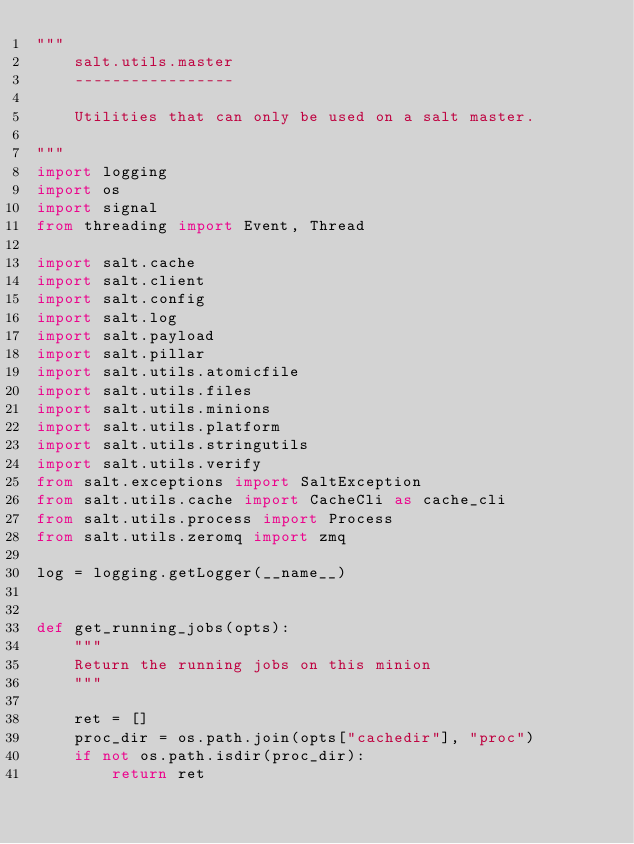Convert code to text. <code><loc_0><loc_0><loc_500><loc_500><_Python_>"""
    salt.utils.master
    -----------------

    Utilities that can only be used on a salt master.

"""
import logging
import os
import signal
from threading import Event, Thread

import salt.cache
import salt.client
import salt.config
import salt.log
import salt.payload
import salt.pillar
import salt.utils.atomicfile
import salt.utils.files
import salt.utils.minions
import salt.utils.platform
import salt.utils.stringutils
import salt.utils.verify
from salt.exceptions import SaltException
from salt.utils.cache import CacheCli as cache_cli
from salt.utils.process import Process
from salt.utils.zeromq import zmq

log = logging.getLogger(__name__)


def get_running_jobs(opts):
    """
    Return the running jobs on this minion
    """

    ret = []
    proc_dir = os.path.join(opts["cachedir"], "proc")
    if not os.path.isdir(proc_dir):
        return ret</code> 